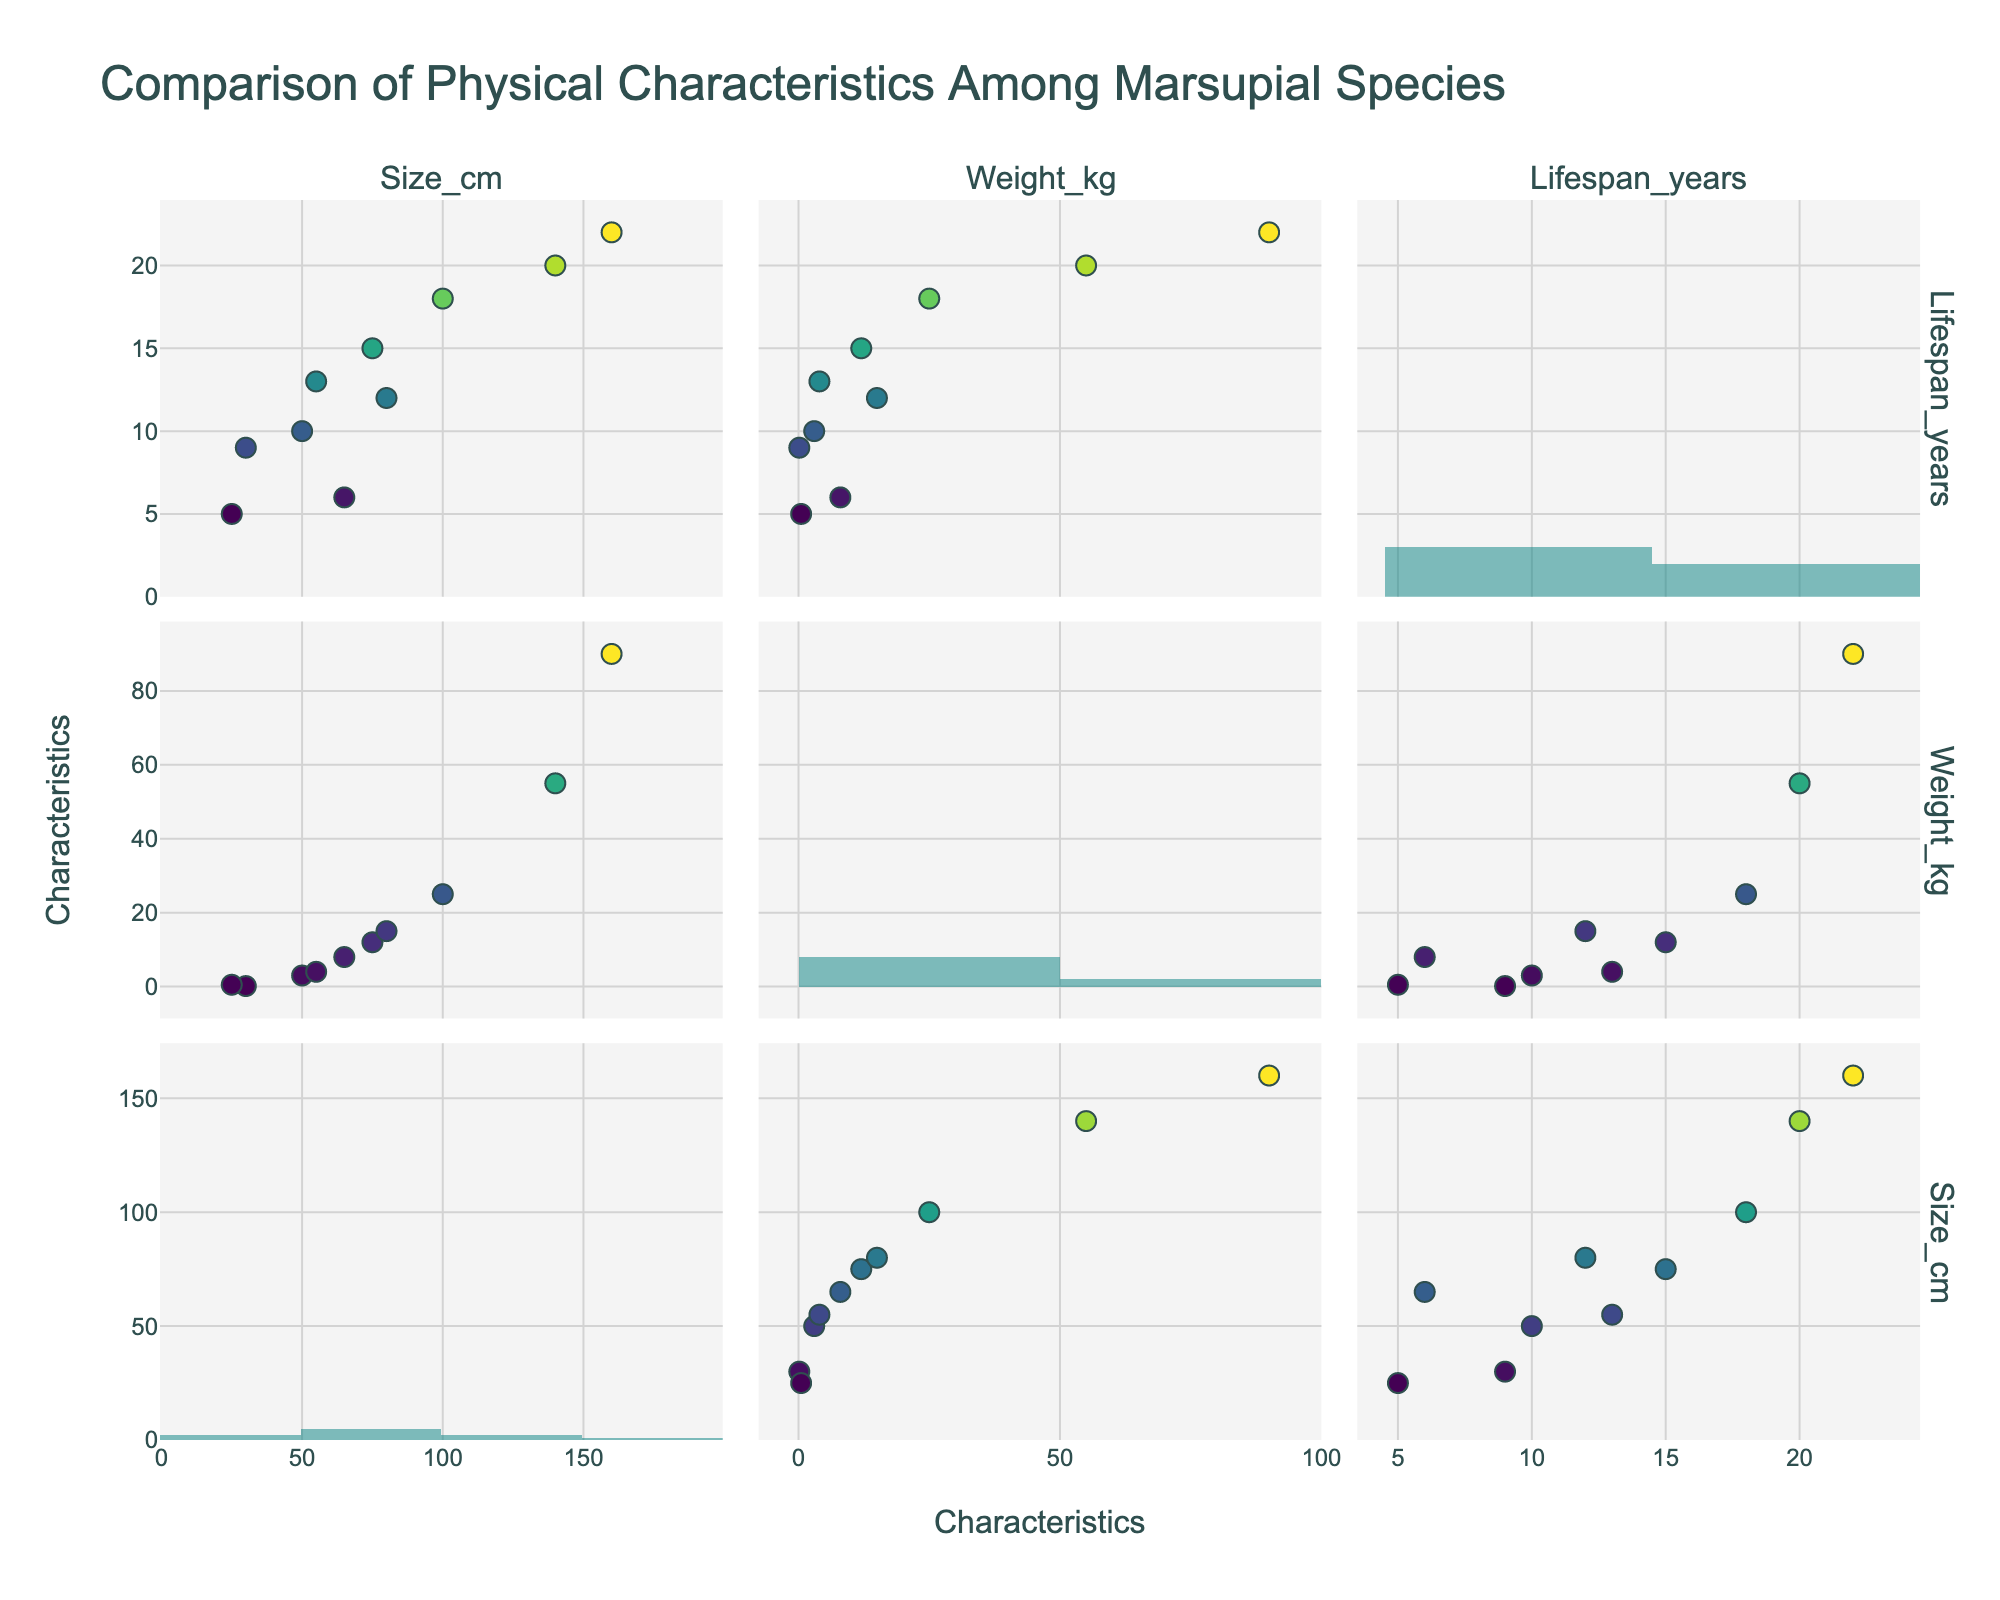What is the title of the plot? The title of the plot can be found at the top of the figure, clearly indicating the subject of the plot.
Answer: Comparison of Physical Characteristics Among Marsupial Species How many data points are there for the 'Size_cm' vs. 'Weight_kg' scatterplot? To find the number of data points for the 'Size_cm' vs. 'Weight_kg' scatterplot, look at the scatterplot positioned in the first row and second column of the matrix. Count the number of points visually.
Answer: 10 Which characteristic shows the greatest range of values among the species in a histogram? To determine the characteristic with the greatest range of values, examine the histograms along the diagonal. The range can be visually estimated by noting the span from the smallest to the largest value in each histogram.
Answer: Size_cm What species has the highest weight? Look at the scatter plots and hover over the points to see the species names and their corresponding weights. Identify the species with the highest weight value.
Answer: Red Kangaroo Which pair of characteristics has a positive correlation? To determine which pair of characteristics has a positive correlation, look at the scatter plots and see which plot shows points trending upwards from left to right.
Answer: Size_cm vs. Weight_kg Is the lifespan of the Koala longer than that of the Tasmanian Devil? Locate the points corresponding to the Koala and Tasmanian Devil on the scatterplot for Size_cm vs. Lifespan_years (third row, first column). Compare their lifespans.
Answer: Yes Which characteristic of marsupials has the least variation among species? To find the characteristic with the least variation, examine the histograms along the diagonal and see which one shows the narrowest range of values.
Answer: Weight_kg Among Koalas, Common Wombats, and Numbats, which species has the shortest lifespan? Locate the points for Koalas, Common Wombats, and Numbats on the scatterplot for Size_cm vs. Lifespan_years. Compare their lifespans.
Answer: Numbat Does the Eastern Grey Kangaroo have a longer lifespan than the Swamp Wallaby? Find the Eastern Grey Kangaroo and Swamp Wallaby on the scatterplot for Size_cm vs. Lifespan_years, and compare their corresponding lifespans.
Answer: Yes Is there any species that has a size greater than 100 cm but a weight less than 25 kg? Examine the scatterplot for Size_cm vs. Weight_kg. If a point exists in the region where Size_cm > 100 cm and Weight_kg < 25 kg, then it meets the criteria.
Answer: No 